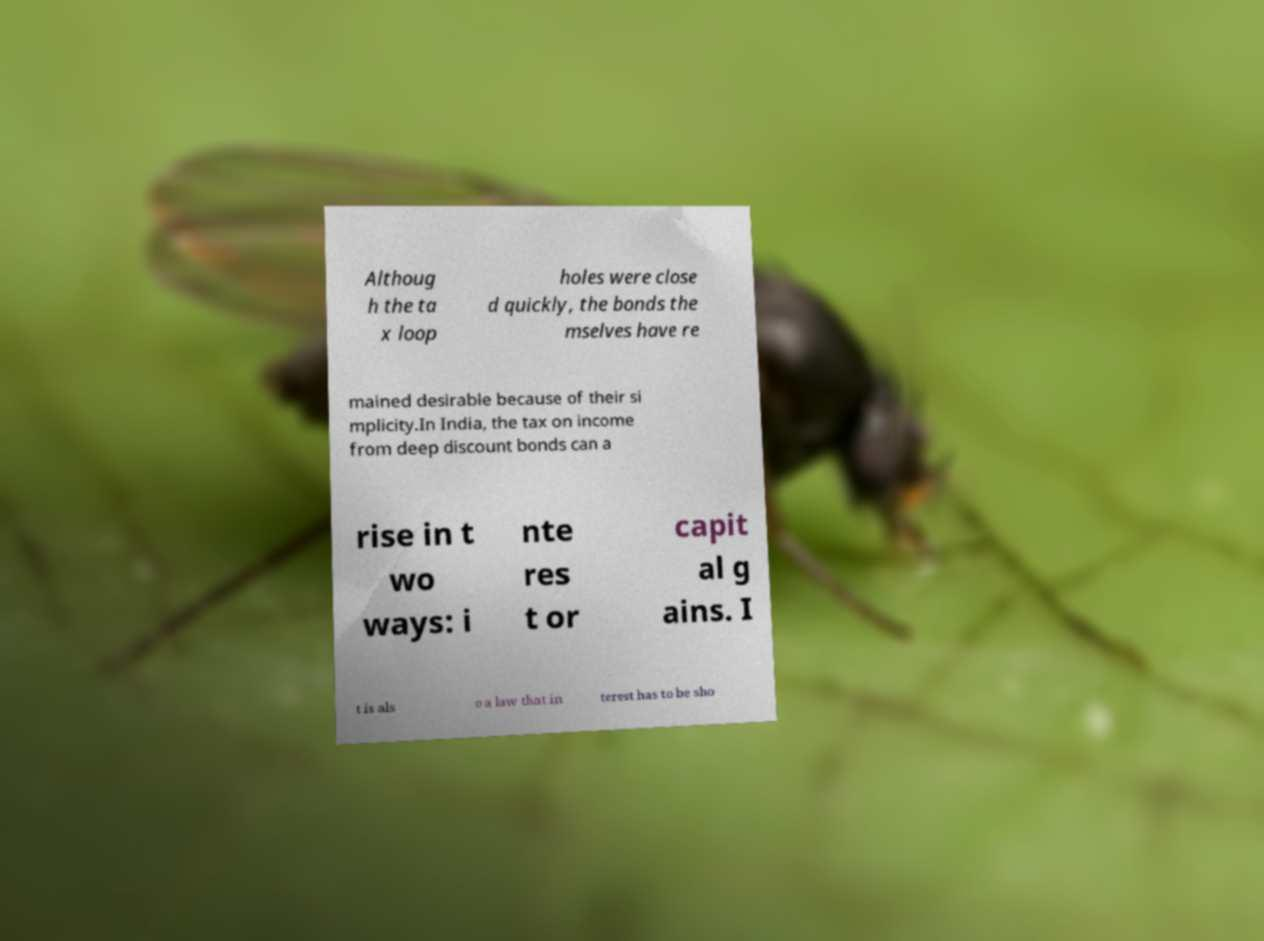Please read and relay the text visible in this image. What does it say? Althoug h the ta x loop holes were close d quickly, the bonds the mselves have re mained desirable because of their si mplicity.In India, the tax on income from deep discount bonds can a rise in t wo ways: i nte res t or capit al g ains. I t is als o a law that in terest has to be sho 